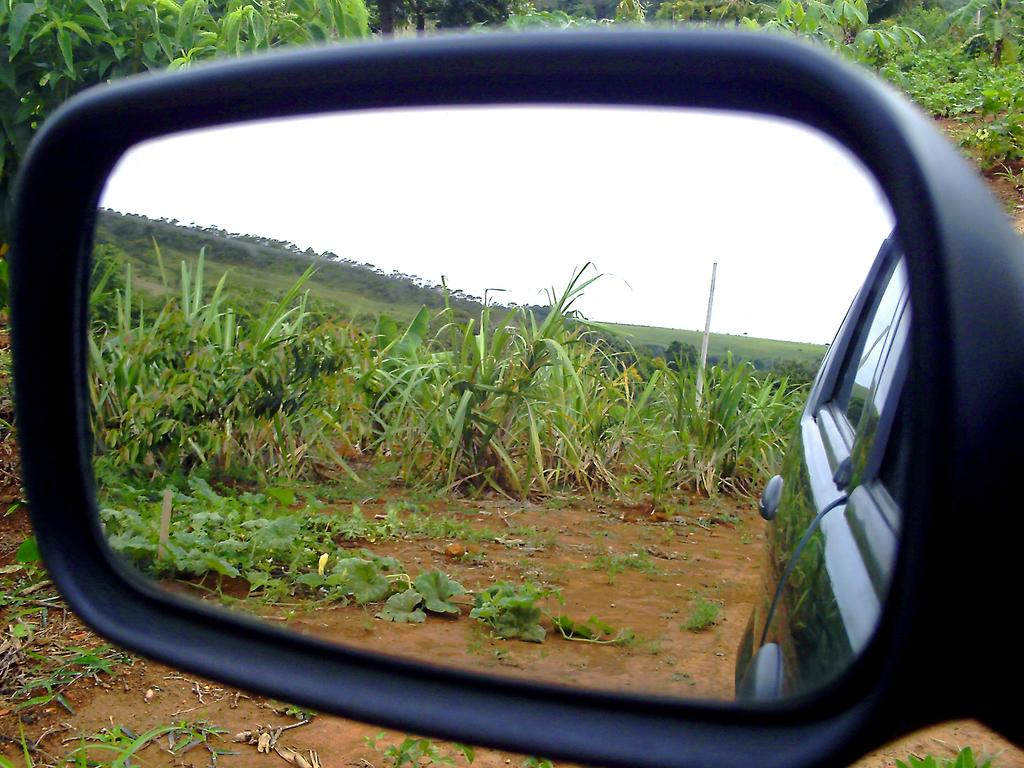What type of reflection can be seen in the image? There are reflections of plants, a pole, a car, and the sky in the image. What is visible at the top of the image? There are plants visible at the top of the image. What type of company is responsible for managing the place in the image? There is no information about a company or place in the image, as it primarily features reflections of various objects. 